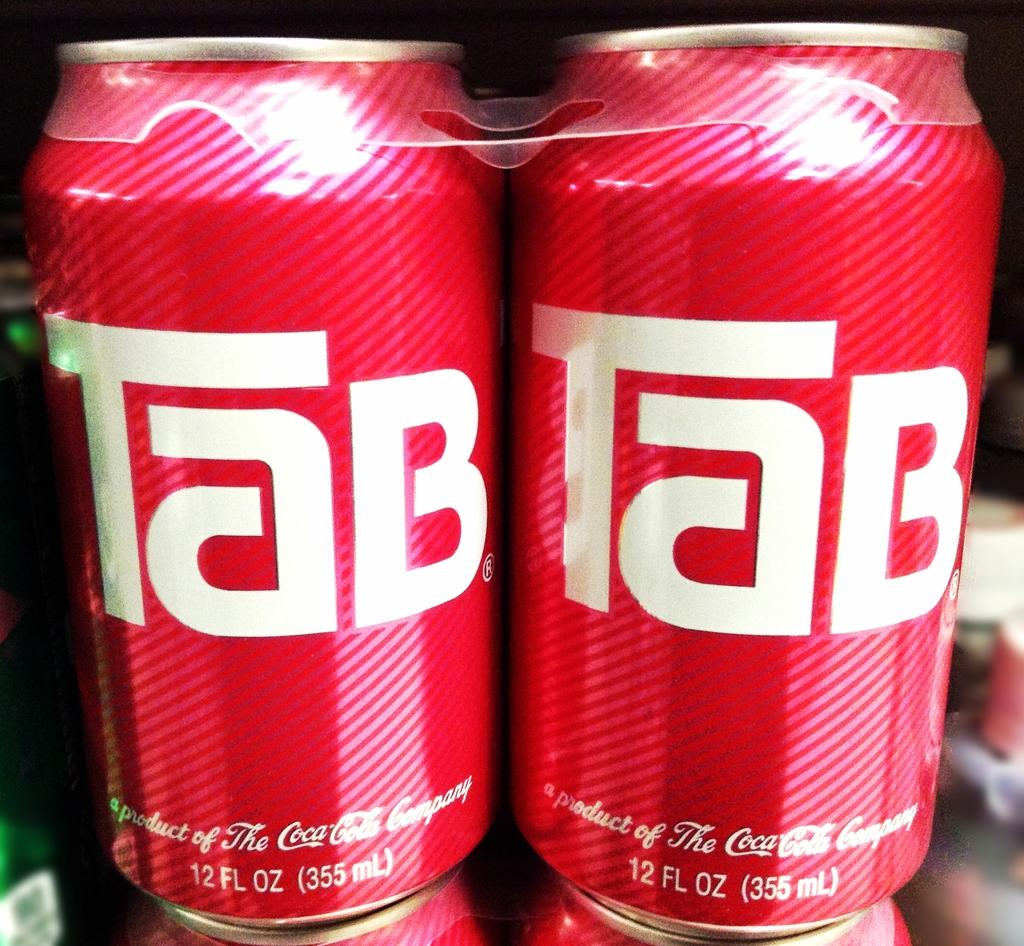<image>
Offer a succinct explanation of the picture presented. The can of Tab soda is from Coca-Cola 